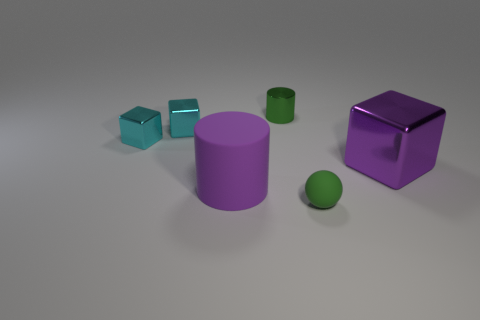Are there any indications about the physical context of where these objects are placed? From the image, we can observe that the objects are placed on a flat, neutral-toned surface with a horizon line implying a spacious environment. There are no additional items or background features that provide a specific physical context, suggesting that the focus is solely on the objects themselves, possibly for illustrative, educational, or artistic purposes. 